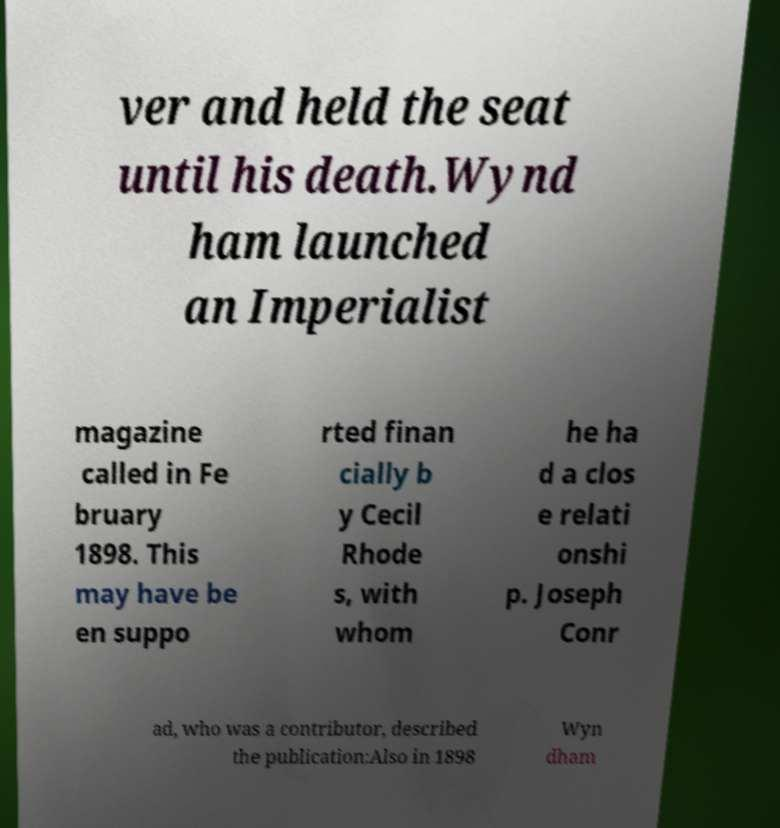For documentation purposes, I need the text within this image transcribed. Could you provide that? ver and held the seat until his death.Wynd ham launched an Imperialist magazine called in Fe bruary 1898. This may have be en suppo rted finan cially b y Cecil Rhode s, with whom he ha d a clos e relati onshi p. Joseph Conr ad, who was a contributor, described the publication:Also in 1898 Wyn dham 